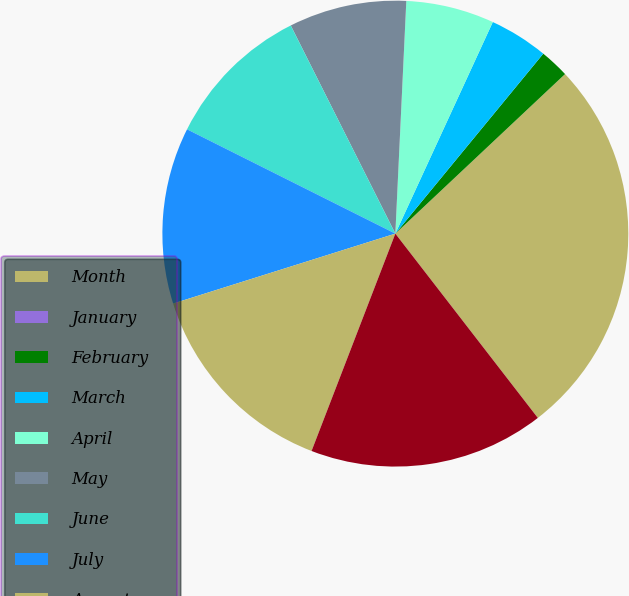<chart> <loc_0><loc_0><loc_500><loc_500><pie_chart><fcel>Month<fcel>January<fcel>February<fcel>March<fcel>April<fcel>May<fcel>June<fcel>July<fcel>August<fcel>September<nl><fcel>26.53%<fcel>0.0%<fcel>2.04%<fcel>4.08%<fcel>6.12%<fcel>8.16%<fcel>10.2%<fcel>12.24%<fcel>14.29%<fcel>16.33%<nl></chart> 